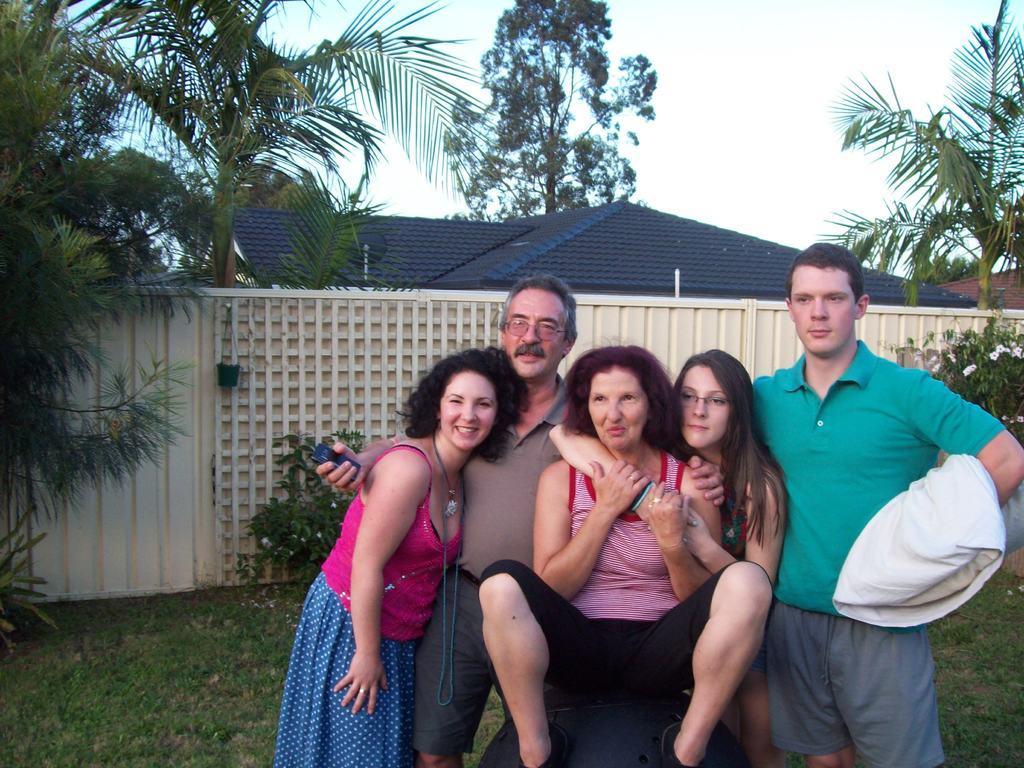Describe this image in one or two sentences. In this picture I can see there are two men and three women and the man at left is holding a black color object and is wearing spectacles. The man to the right is holding a pillow and there is some grass on the floor, there are few plants in the backdrop and there is a wall, trees and a building. The sky is clear. 